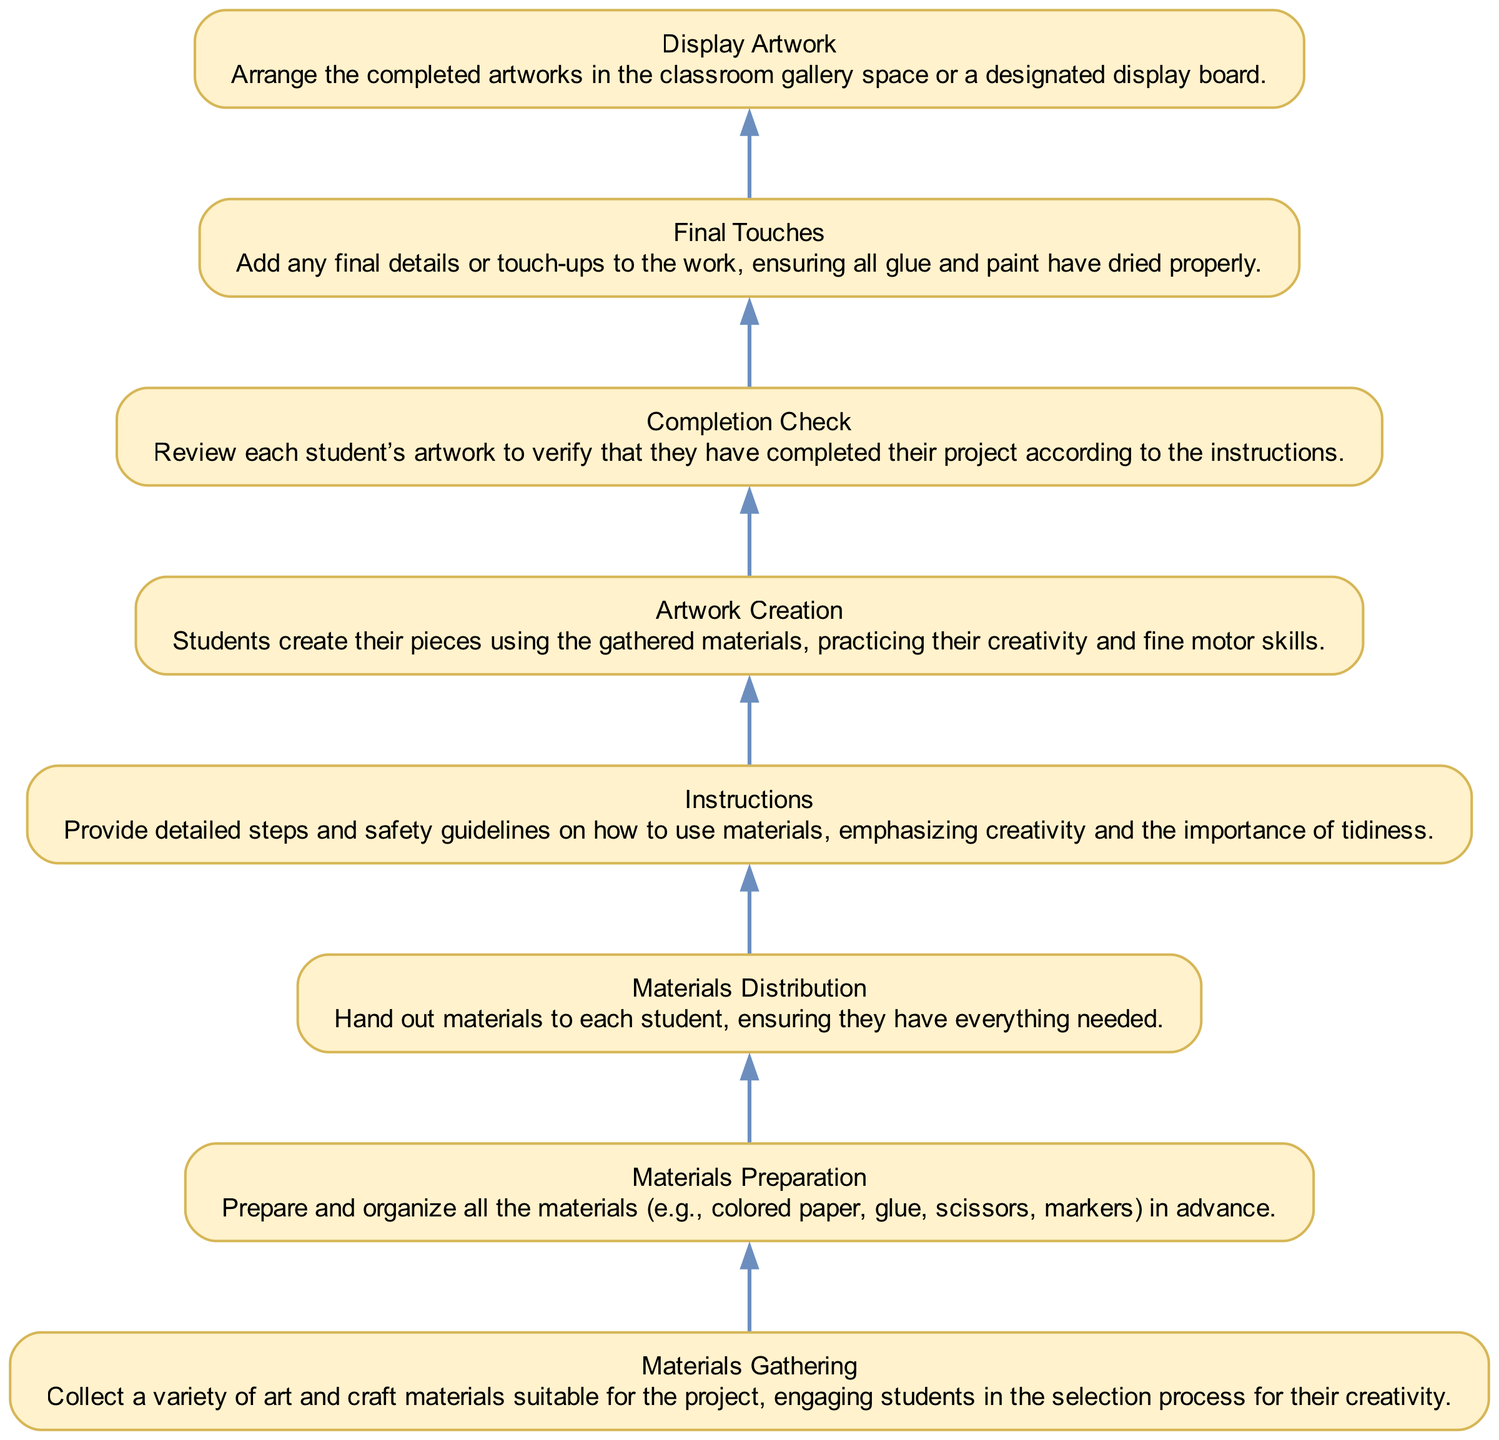What is the first step in the diagram? The first step in the diagram is "Display Artwork," which is the topmost node indicating that completed artworks are arranged in a designated space.
Answer: Display Artwork How many nodes are there in total? By counting all the distinct elements in the list, there are a total of 8 nodes corresponding to different steps in the project execution.
Answer: 8 Which step follows "Materials Distribution"? The step that immediately follows "Materials Distribution" in the diagram as indicated by the edges is "Artwork Creation," which is the next action that takes place after distributing materials.
Answer: Artwork Creation What is the last step before displaying the artwork? The last step before displaying the artwork is "Final Touches," which is crucial in ensuring that the artwork is complete and ready to be showcased.
Answer: Final Touches In which step do students practice their creativity? In the diagram, students practice their creativity during the step "Artwork Creation," where they create their pieces using the gathered materials.
Answer: Artwork Creation How many edges are there in the flowchart? The edges connect each node in a sequential flow from bottom to top. Since there are 8 nodes, there will be 7 edges connecting them sequentially.
Answer: 7 What is the relationship between "Materials Gathering" and "Instructions"? The flowchart indicates a direct relationship where "Materials Gathering" is the first step that precedes "Instructions," suggesting that you gather materials before you provide instructions on how to use them.
Answer: "Materials Gathering" precedes "Instructions" What do the final touches ensure? The final touches ensure that all glue and paint have dried properly and that the artwork is in its best condition before it is displayed.
Answer: All glue and paint have dried properly 